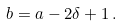Convert formula to latex. <formula><loc_0><loc_0><loc_500><loc_500>b = a - 2 \delta + 1 \, .</formula> 